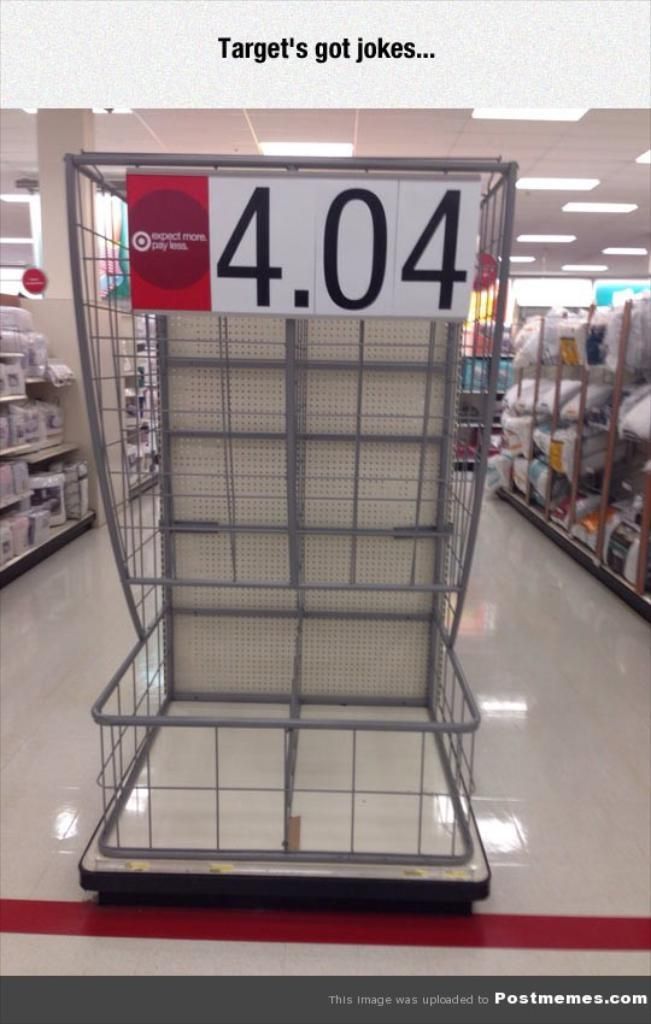What is the primary object in the image? The image appears to be a tray. What can be found on the tray? There is text in the image. Are there any additional features on the tray? Yes, there are racks on either side of the image. What type of land is visible in the image? There is no land visible in the image; it is a tray with text and racks. What kind of doctor is present in the image? There is no doctor present in the image; it is a tray with text and racks. 